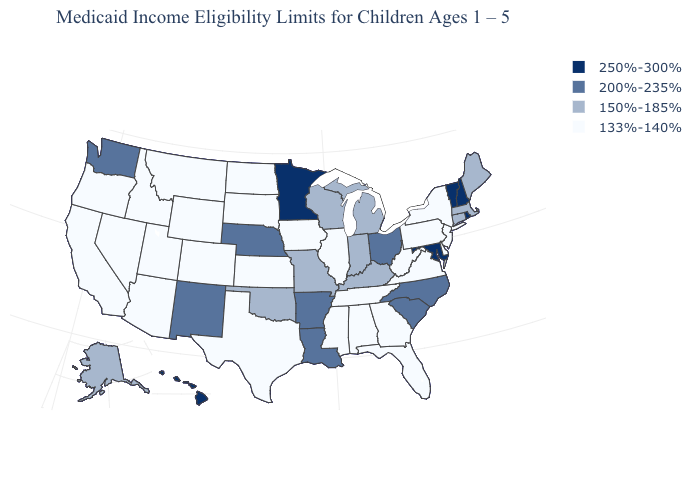Name the states that have a value in the range 133%-140%?
Concise answer only. Alabama, Arizona, California, Colorado, Delaware, Florida, Georgia, Idaho, Illinois, Iowa, Kansas, Mississippi, Montana, Nevada, New Jersey, New York, North Dakota, Oregon, Pennsylvania, South Dakota, Tennessee, Texas, Utah, Virginia, West Virginia, Wyoming. What is the value of Iowa?
Answer briefly. 133%-140%. Name the states that have a value in the range 150%-185%?
Give a very brief answer. Alaska, Connecticut, Indiana, Kentucky, Maine, Massachusetts, Michigan, Missouri, Oklahoma, Wisconsin. What is the value of Kentucky?
Short answer required. 150%-185%. What is the value of Vermont?
Short answer required. 250%-300%. Among the states that border New York , does Vermont have the lowest value?
Concise answer only. No. What is the value of Oregon?
Keep it brief. 133%-140%. Among the states that border Colorado , which have the lowest value?
Be succinct. Arizona, Kansas, Utah, Wyoming. Does Connecticut have the same value as Colorado?
Concise answer only. No. Name the states that have a value in the range 150%-185%?
Concise answer only. Alaska, Connecticut, Indiana, Kentucky, Maine, Massachusetts, Michigan, Missouri, Oklahoma, Wisconsin. What is the highest value in the USA?
Be succinct. 250%-300%. Name the states that have a value in the range 150%-185%?
Short answer required. Alaska, Connecticut, Indiana, Kentucky, Maine, Massachusetts, Michigan, Missouri, Oklahoma, Wisconsin. Name the states that have a value in the range 200%-235%?
Short answer required. Arkansas, Louisiana, Nebraska, New Mexico, North Carolina, Ohio, South Carolina, Washington. What is the value of Florida?
Quick response, please. 133%-140%. Does the first symbol in the legend represent the smallest category?
Quick response, please. No. 